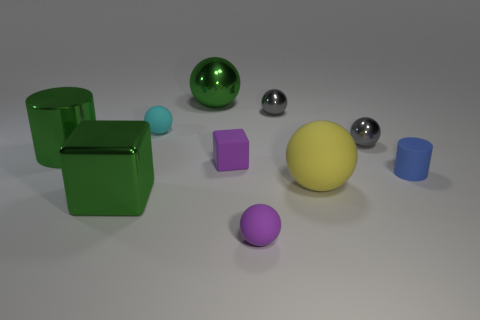The large thing right of the big green thing that is behind the ball on the left side of the big green sphere is made of what material?
Your answer should be very brief. Rubber. There is a yellow ball that is in front of the large green shiny cylinder; what is it made of?
Give a very brief answer. Rubber. Is there a green cube of the same size as the yellow ball?
Your response must be concise. Yes. There is a tiny thing that is in front of the tiny blue rubber cylinder; is it the same color as the big cylinder?
Provide a short and direct response. No. What number of green things are either rubber spheres or big metallic cubes?
Ensure brevity in your answer.  1. What number of small rubber things have the same color as the rubber cube?
Offer a terse response. 1. Do the big green cylinder and the tiny blue cylinder have the same material?
Your response must be concise. No. There is a gray metal object left of the yellow rubber sphere; how many matte things are on the left side of it?
Provide a succinct answer. 3. Is the yellow rubber sphere the same size as the green cylinder?
Give a very brief answer. Yes. What number of small purple balls are the same material as the yellow ball?
Offer a terse response. 1. 